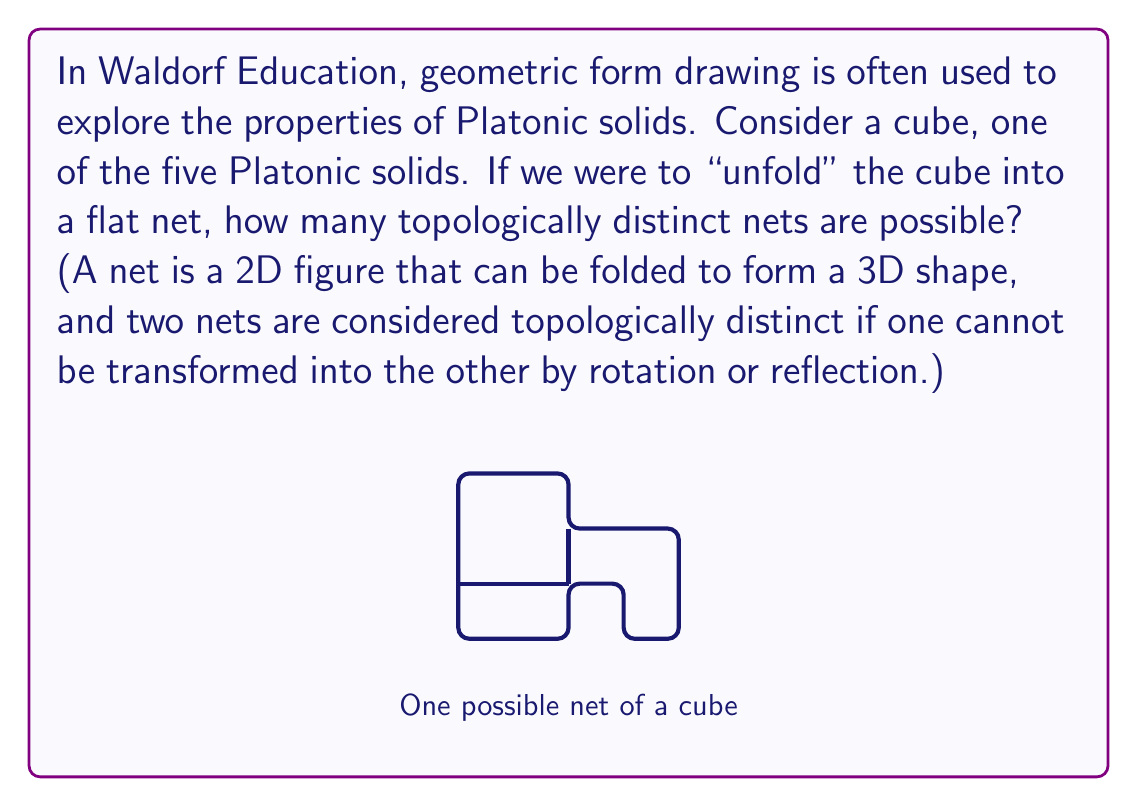Show me your answer to this math problem. To approach this problem, let's consider the properties of a cube and how they relate to its nets:

1) A cube has 6 faces, each of which is a square.

2) In a net, these 6 squares must be connected, forming a single piece.

3) When folded, each edge of the cube must correspond to two adjacent squares in the net.

4) The net must not overlap itself when folded.

To count the distinct nets:

1) We can start with one square and consider all ways to attach the other 5 squares.

2) The key is to realize that the arrangement of squares around each vertex of the cube is crucial. Each vertex in the folded cube connects three faces.

3) There are several ways to arrange three squares around a point in the net, but many of these will result in the same net when rotated or reflected.

4) After careful consideration and elimination of equivalent arrangements, mathematicians have proven that there are exactly 11 distinct nets for a cube.

This problem relates to topology because we're considering the connectivity of the faces rather than their exact geometric positions. It's relevant to Waldorf Education's form drawing as it encourages spatial thinking and understanding of 3D shapes through 2D representations.

The process of discovering these 11 nets can be a valuable exercise in spatial reasoning and geometric exploration, aligning with Waldorf Education's hands-on, experiential learning approach.
Answer: 11 